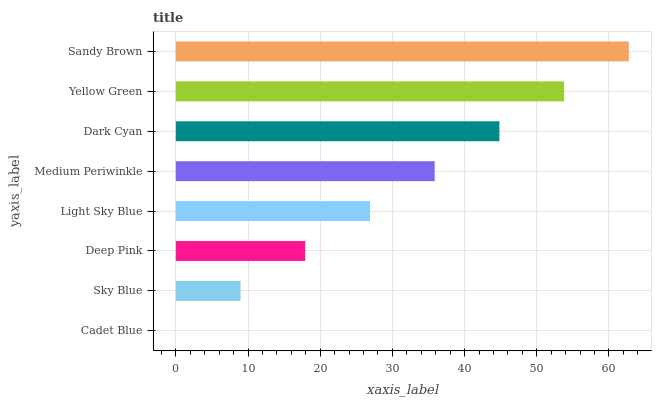Is Cadet Blue the minimum?
Answer yes or no. Yes. Is Sandy Brown the maximum?
Answer yes or no. Yes. Is Sky Blue the minimum?
Answer yes or no. No. Is Sky Blue the maximum?
Answer yes or no. No. Is Sky Blue greater than Cadet Blue?
Answer yes or no. Yes. Is Cadet Blue less than Sky Blue?
Answer yes or no. Yes. Is Cadet Blue greater than Sky Blue?
Answer yes or no. No. Is Sky Blue less than Cadet Blue?
Answer yes or no. No. Is Medium Periwinkle the high median?
Answer yes or no. Yes. Is Light Sky Blue the low median?
Answer yes or no. Yes. Is Deep Pink the high median?
Answer yes or no. No. Is Deep Pink the low median?
Answer yes or no. No. 